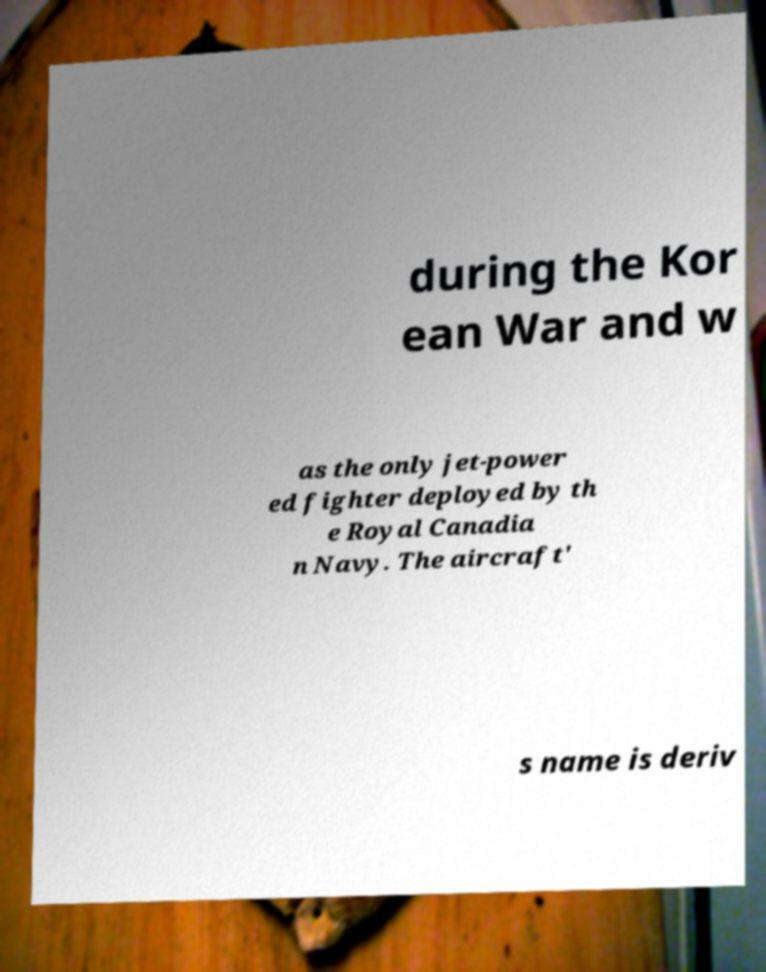Could you assist in decoding the text presented in this image and type it out clearly? during the Kor ean War and w as the only jet-power ed fighter deployed by th e Royal Canadia n Navy. The aircraft' s name is deriv 